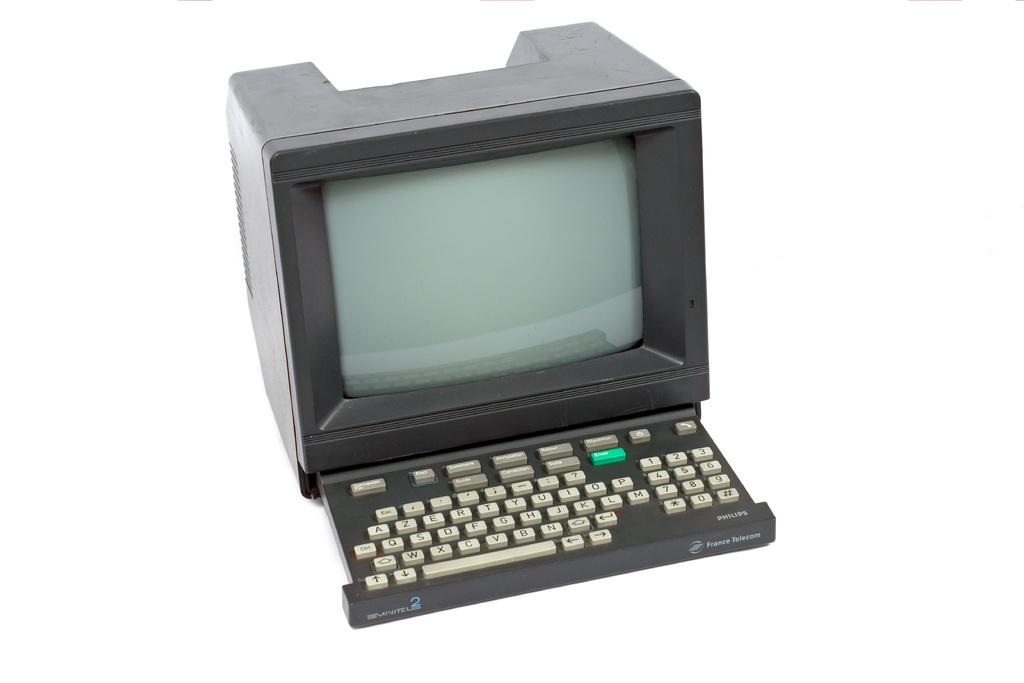What electronic device is visible in the image? There is a keyboard in the image. What is the keyboard connected to? There is a monitor in the image, which the keyboard is likely connected to. What color is the background of the image? The background of the image is white. How many cherries are on the keyboard in the image? There are no cherries present on the keyboard in the image. What type of gun is visible in the image? There is no gun present in the image. 